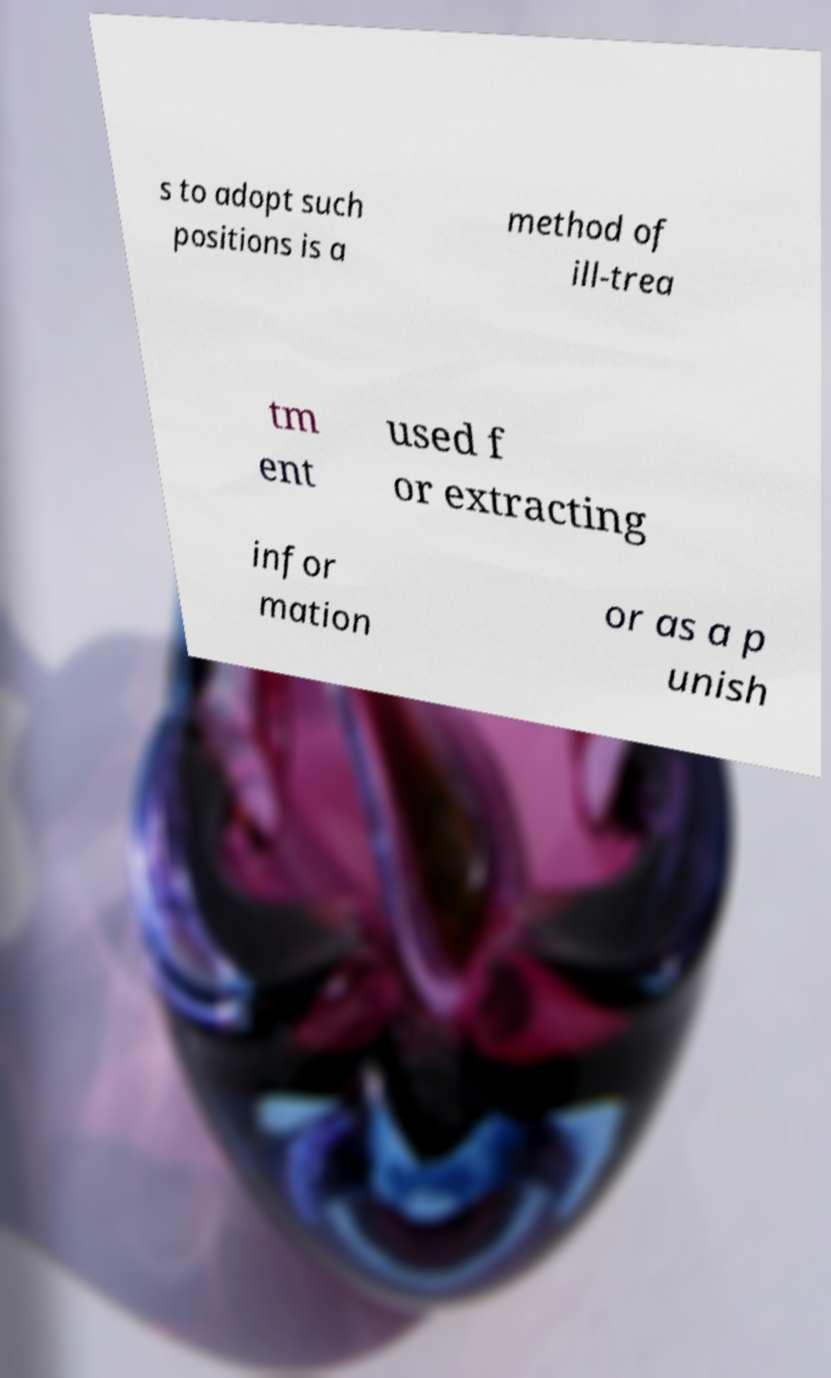Please identify and transcribe the text found in this image. s to adopt such positions is a method of ill-trea tm ent used f or extracting infor mation or as a p unish 